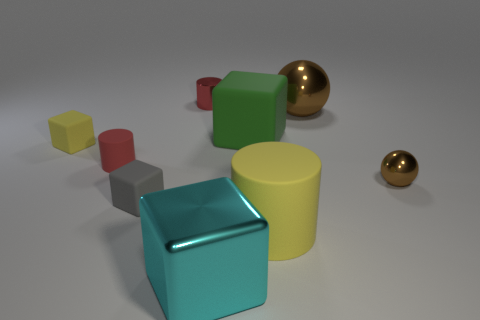Add 1 big purple cubes. How many objects exist? 10 Subtract all spheres. How many objects are left? 7 Subtract all brown rubber spheres. Subtract all small metal balls. How many objects are left? 8 Add 5 shiny cylinders. How many shiny cylinders are left? 6 Add 6 large brown metallic things. How many large brown metallic things exist? 7 Subtract 0 red balls. How many objects are left? 9 